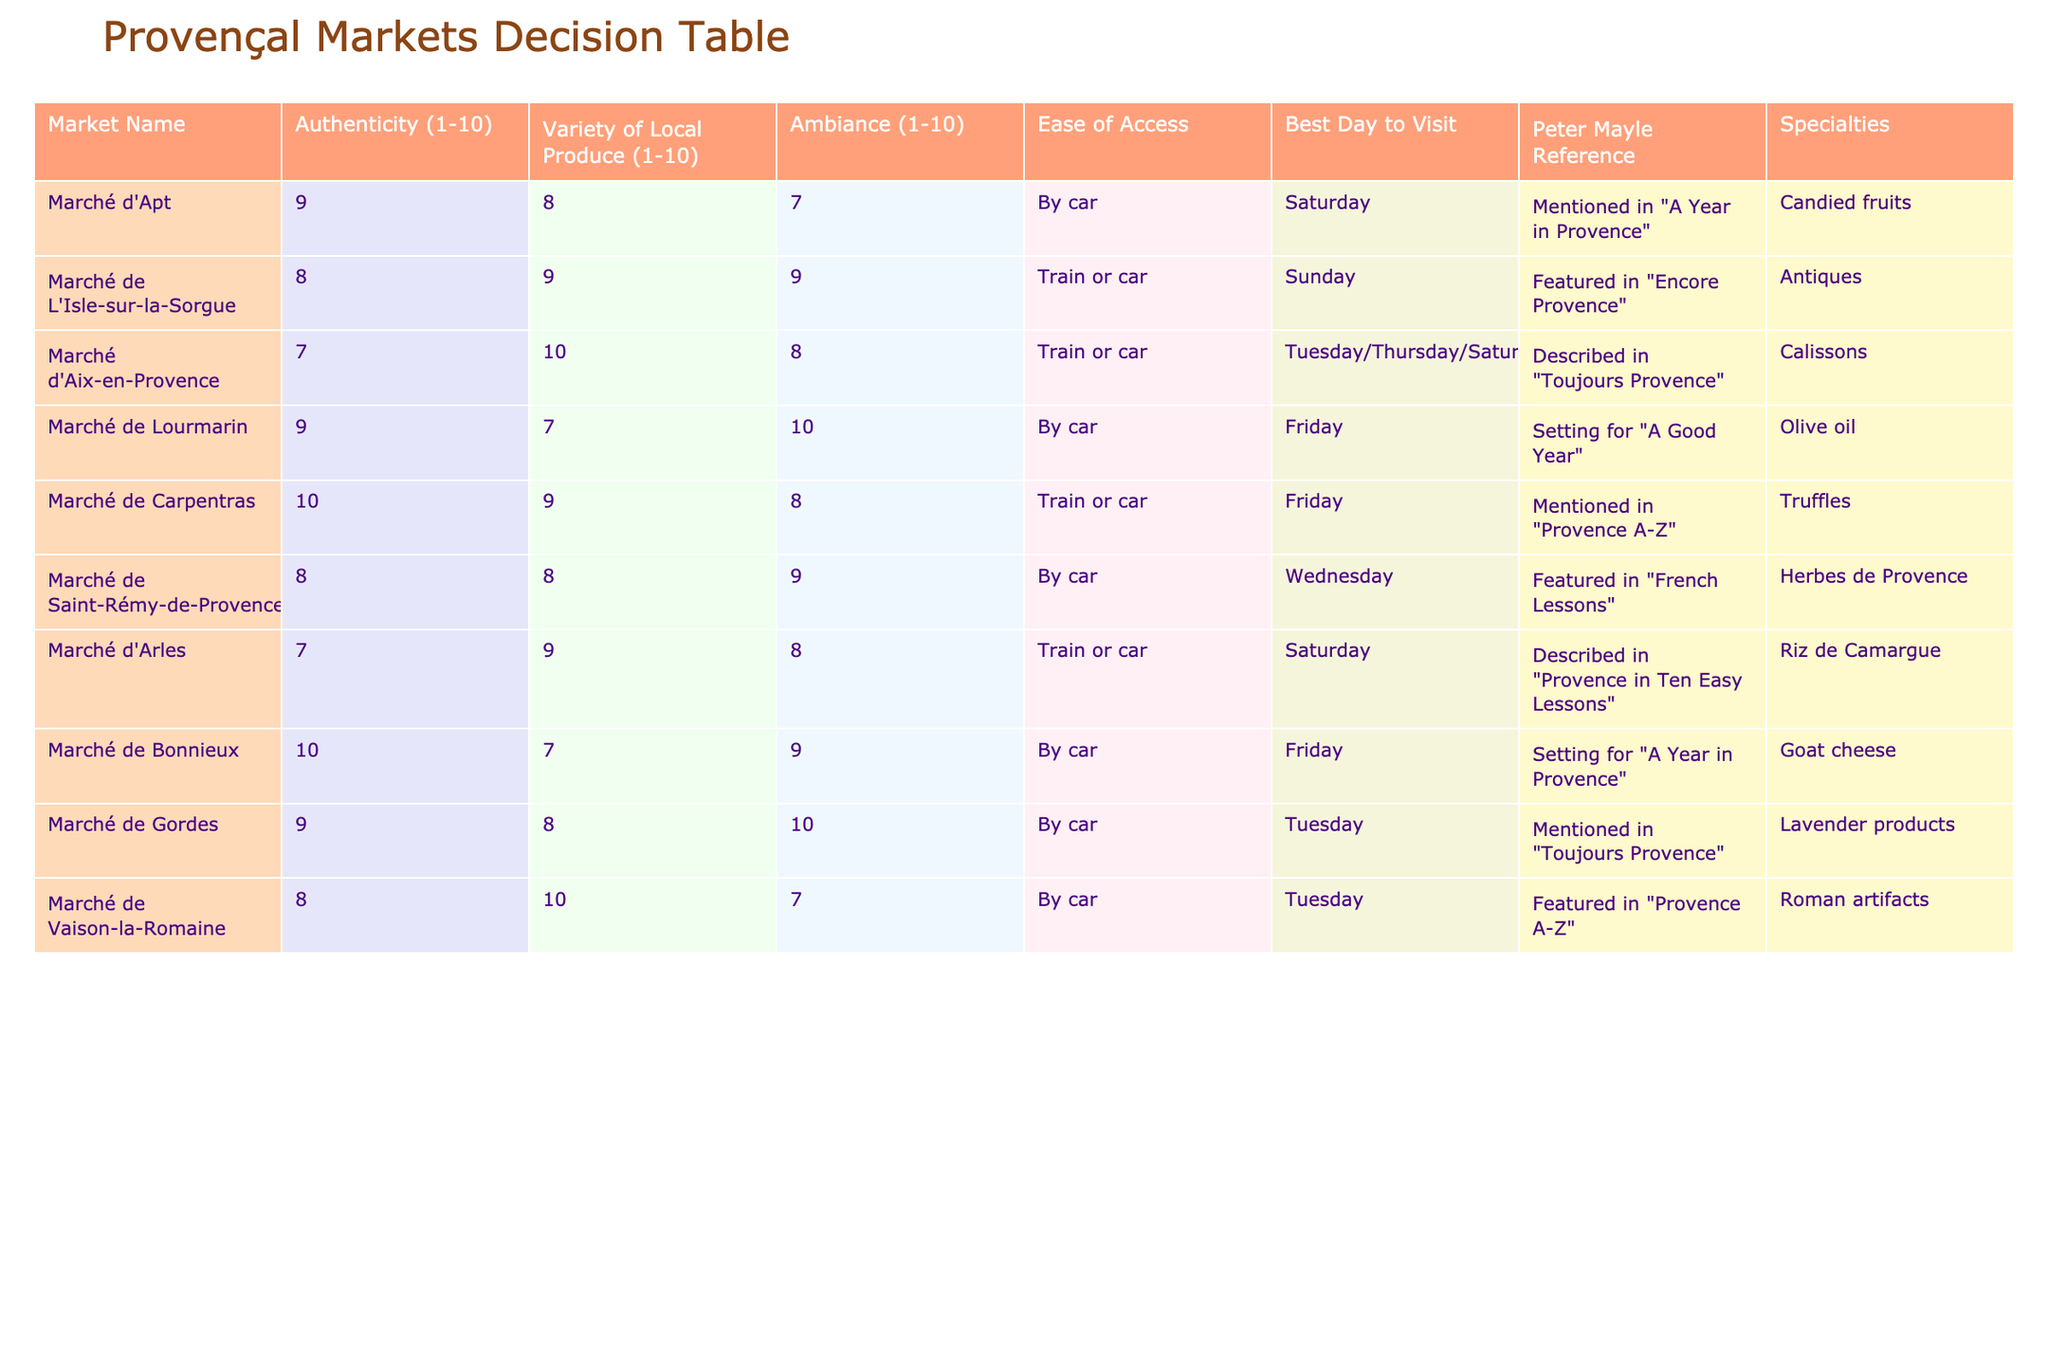What is the best day to visit the Marché de Carpentras? The table indicates that the best day to visit Marché de Carpentras is Friday.
Answer: Friday Which market has the highest authenticity rating? By examining the "Authenticity" column in the table, Marché de Carpentras has the highest authenticity rating of 10.
Answer: Marché de Carpentras What is the average variety of local produce rating across all markets? To find the average, sum the ratings: (8 + 9 + 10 + 7 + 9 + 8 + 9 + 7 + 8 + 10) = 81. There are 10 markets, so the average is 81/10 = 8.1.
Answer: 8.1 Does Marché d'Apt specialize in truffles? According to the "Specialties" column, Marché d'Apt specializes in candied fruits, not truffles.
Answer: No Which market combines high authenticity and ambiance, both rated 9 or higher? Looking at the "Authenticity" and "Ambiance" columns, Marché de Carpentras (10,8) and Marché de Lourmarin (9,10) meet this criteria.
Answer: Marché de Carpentras, Marché de Lourmarin How many markets are accessible by train or car? The "Ease of Access" column indicates that 5 markets (Marché de L'Isle-sur-la-Sorgue, Marché d'Aix-en-Provence, Marché de Carpentras, Marché d'Arles, Marché de Vaison-la-Romaine) can be accessed by train or car.
Answer: 5 What is the ambiance rating of the Marché de Lourmarin? Referring to the "Ambiance" column, Marché de Lourmarin has an ambiance rating of 10.
Answer: 10 Is Aix-en-Provence mentioned in Peter Mayle's books? The table notes that Marché d'Aix-en-Provence is described in "Toujours Provence," confirming the reference.
Answer: Yes Which market offers the specialty of goat cheese? According to the "Specialties" column, Marché de Bonnieux offers goat cheese.
Answer: Marché de Bonnieux 